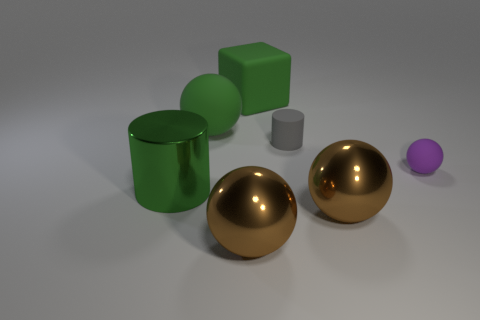Is the color of the cylinder left of the large green matte ball the same as the cylinder that is behind the green metal cylinder?
Offer a terse response. No. There is a big green sphere; how many tiny rubber spheres are behind it?
Your response must be concise. 0. There is a ball that is the same color as the block; what is it made of?
Keep it short and to the point. Rubber. Are there any tiny rubber things of the same shape as the green metallic thing?
Make the answer very short. Yes. Do the cylinder behind the green metal cylinder and the small purple ball on the right side of the matte cube have the same material?
Your response must be concise. Yes. What is the size of the rubber ball behind the matte sphere that is on the right side of the small thing to the left of the purple matte thing?
Offer a very short reply. Large. There is a sphere that is the same size as the gray thing; what is its material?
Your response must be concise. Rubber. Are there any brown things that have the same size as the green block?
Offer a very short reply. Yes. Is the big green metal object the same shape as the tiny purple object?
Offer a terse response. No. Are there any large things in front of the large ball behind the rubber sphere that is in front of the small cylinder?
Your response must be concise. Yes. 